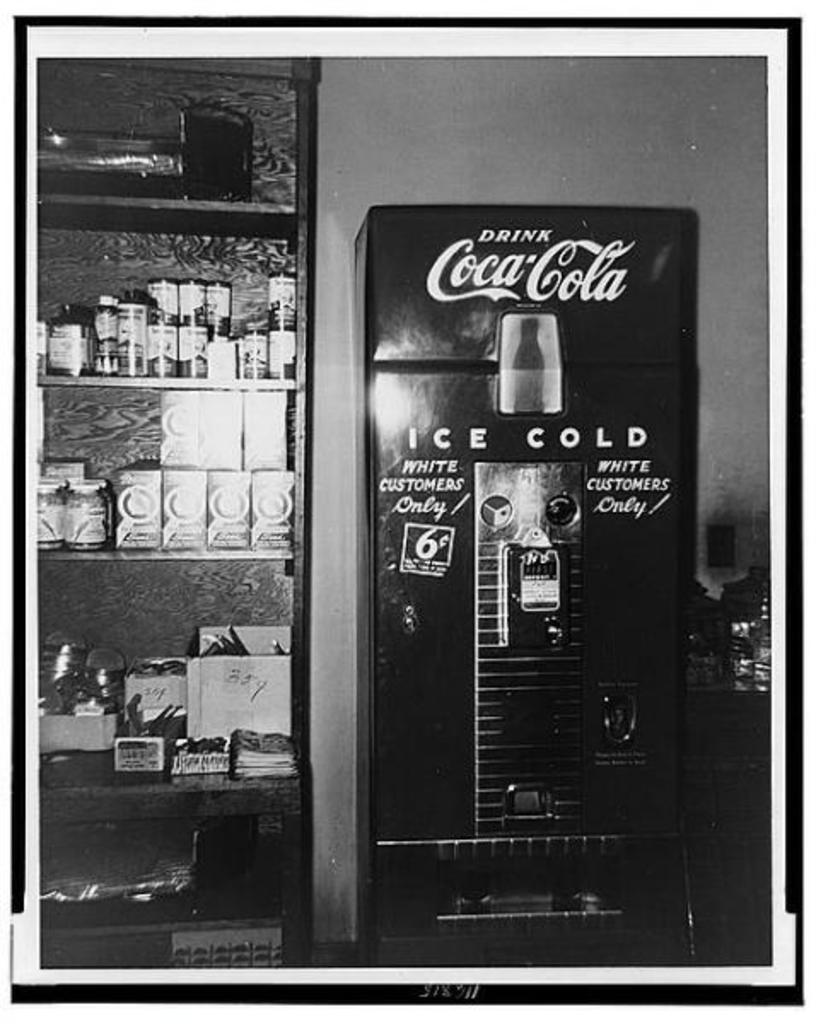<image>
Describe the image concisely. An old Coca Cola drink box intended for white customers only! 